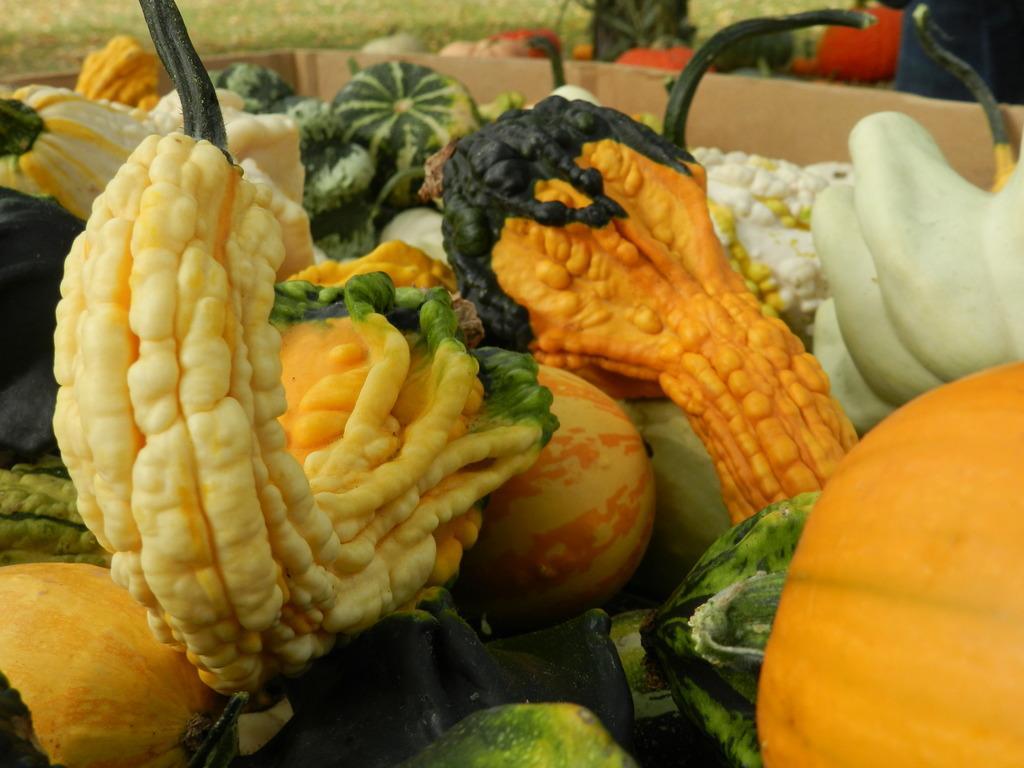In one or two sentences, can you explain what this image depicts? In this image we can see some vegetable, and fruits in a box, and the background is blurred. 